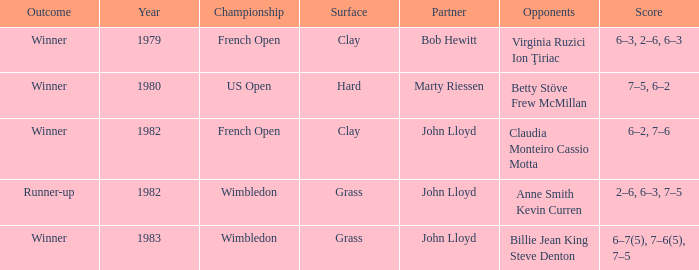Which opponents contributed to a winning outcome on a grassy terrain? Billie Jean King Steve Denton. 